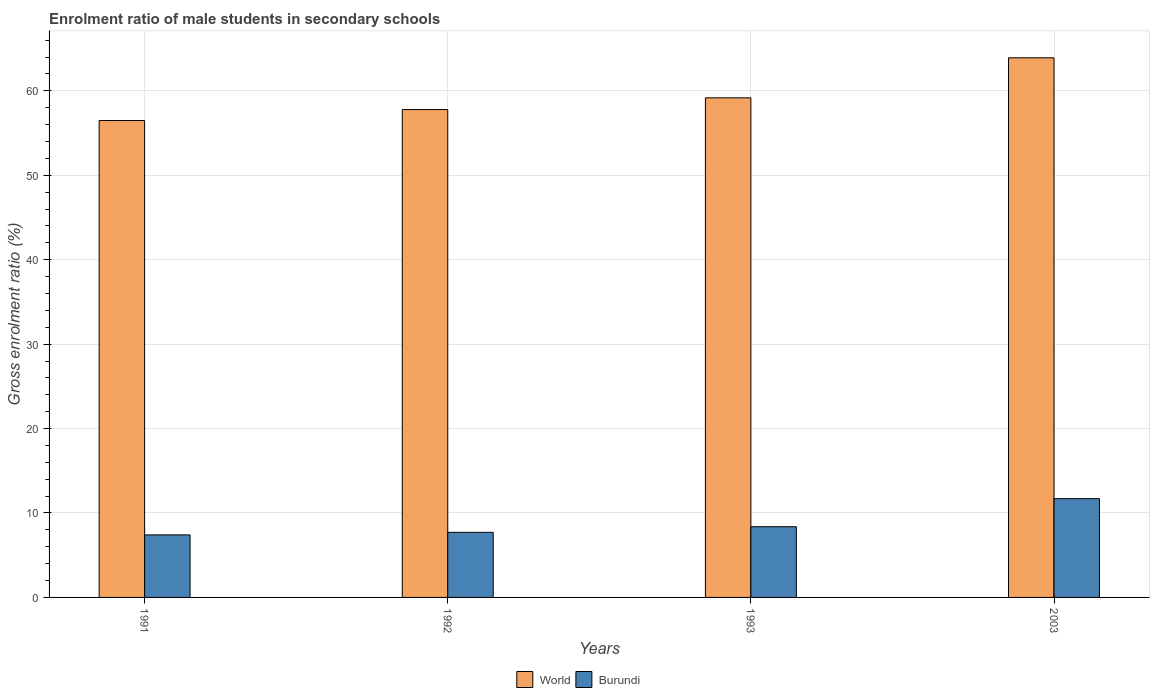How many groups of bars are there?
Offer a terse response. 4. What is the enrolment ratio of male students in secondary schools in Burundi in 2003?
Make the answer very short. 11.7. Across all years, what is the maximum enrolment ratio of male students in secondary schools in World?
Ensure brevity in your answer.  63.91. Across all years, what is the minimum enrolment ratio of male students in secondary schools in World?
Give a very brief answer. 56.48. In which year was the enrolment ratio of male students in secondary schools in Burundi maximum?
Provide a succinct answer. 2003. In which year was the enrolment ratio of male students in secondary schools in Burundi minimum?
Your answer should be very brief. 1991. What is the total enrolment ratio of male students in secondary schools in Burundi in the graph?
Provide a short and direct response. 35.18. What is the difference between the enrolment ratio of male students in secondary schools in World in 1991 and that in 2003?
Your answer should be very brief. -7.43. What is the difference between the enrolment ratio of male students in secondary schools in World in 1993 and the enrolment ratio of male students in secondary schools in Burundi in 1991?
Offer a very short reply. 51.77. What is the average enrolment ratio of male students in secondary schools in World per year?
Provide a succinct answer. 59.34. In the year 1992, what is the difference between the enrolment ratio of male students in secondary schools in Burundi and enrolment ratio of male students in secondary schools in World?
Provide a short and direct response. -50.07. What is the ratio of the enrolment ratio of male students in secondary schools in Burundi in 1991 to that in 2003?
Keep it short and to the point. 0.63. What is the difference between the highest and the second highest enrolment ratio of male students in secondary schools in Burundi?
Offer a very short reply. 3.32. What is the difference between the highest and the lowest enrolment ratio of male students in secondary schools in Burundi?
Give a very brief answer. 4.29. In how many years, is the enrolment ratio of male students in secondary schools in World greater than the average enrolment ratio of male students in secondary schools in World taken over all years?
Your answer should be very brief. 1. What does the 2nd bar from the left in 2003 represents?
Your answer should be compact. Burundi. What does the 1st bar from the right in 1991 represents?
Offer a terse response. Burundi. Are all the bars in the graph horizontal?
Provide a succinct answer. No. Are the values on the major ticks of Y-axis written in scientific E-notation?
Offer a very short reply. No. Does the graph contain grids?
Ensure brevity in your answer.  Yes. Where does the legend appear in the graph?
Ensure brevity in your answer.  Bottom center. How many legend labels are there?
Offer a terse response. 2. What is the title of the graph?
Make the answer very short. Enrolment ratio of male students in secondary schools. Does "Albania" appear as one of the legend labels in the graph?
Provide a succinct answer. No. What is the label or title of the X-axis?
Provide a short and direct response. Years. What is the Gross enrolment ratio (%) in World in 1991?
Keep it short and to the point. 56.48. What is the Gross enrolment ratio (%) in Burundi in 1991?
Keep it short and to the point. 7.41. What is the Gross enrolment ratio (%) of World in 1992?
Your response must be concise. 57.78. What is the Gross enrolment ratio (%) in Burundi in 1992?
Offer a terse response. 7.71. What is the Gross enrolment ratio (%) in World in 1993?
Give a very brief answer. 59.17. What is the Gross enrolment ratio (%) in Burundi in 1993?
Your response must be concise. 8.37. What is the Gross enrolment ratio (%) in World in 2003?
Give a very brief answer. 63.91. What is the Gross enrolment ratio (%) of Burundi in 2003?
Provide a short and direct response. 11.7. Across all years, what is the maximum Gross enrolment ratio (%) in World?
Offer a very short reply. 63.91. Across all years, what is the maximum Gross enrolment ratio (%) of Burundi?
Make the answer very short. 11.7. Across all years, what is the minimum Gross enrolment ratio (%) of World?
Provide a succinct answer. 56.48. Across all years, what is the minimum Gross enrolment ratio (%) of Burundi?
Your response must be concise. 7.41. What is the total Gross enrolment ratio (%) of World in the graph?
Offer a very short reply. 237.34. What is the total Gross enrolment ratio (%) in Burundi in the graph?
Give a very brief answer. 35.19. What is the difference between the Gross enrolment ratio (%) in World in 1991 and that in 1992?
Your response must be concise. -1.3. What is the difference between the Gross enrolment ratio (%) in Burundi in 1991 and that in 1992?
Keep it short and to the point. -0.3. What is the difference between the Gross enrolment ratio (%) of World in 1991 and that in 1993?
Offer a very short reply. -2.69. What is the difference between the Gross enrolment ratio (%) of Burundi in 1991 and that in 1993?
Give a very brief answer. -0.97. What is the difference between the Gross enrolment ratio (%) in World in 1991 and that in 2003?
Your answer should be compact. -7.43. What is the difference between the Gross enrolment ratio (%) in Burundi in 1991 and that in 2003?
Your answer should be very brief. -4.29. What is the difference between the Gross enrolment ratio (%) in World in 1992 and that in 1993?
Make the answer very short. -1.39. What is the difference between the Gross enrolment ratio (%) in Burundi in 1992 and that in 1993?
Give a very brief answer. -0.66. What is the difference between the Gross enrolment ratio (%) in World in 1992 and that in 2003?
Give a very brief answer. -6.13. What is the difference between the Gross enrolment ratio (%) in Burundi in 1992 and that in 2003?
Your response must be concise. -3.99. What is the difference between the Gross enrolment ratio (%) of World in 1993 and that in 2003?
Make the answer very short. -4.74. What is the difference between the Gross enrolment ratio (%) in Burundi in 1993 and that in 2003?
Offer a terse response. -3.32. What is the difference between the Gross enrolment ratio (%) in World in 1991 and the Gross enrolment ratio (%) in Burundi in 1992?
Provide a short and direct response. 48.77. What is the difference between the Gross enrolment ratio (%) in World in 1991 and the Gross enrolment ratio (%) in Burundi in 1993?
Make the answer very short. 48.11. What is the difference between the Gross enrolment ratio (%) of World in 1991 and the Gross enrolment ratio (%) of Burundi in 2003?
Give a very brief answer. 44.79. What is the difference between the Gross enrolment ratio (%) in World in 1992 and the Gross enrolment ratio (%) in Burundi in 1993?
Offer a terse response. 49.41. What is the difference between the Gross enrolment ratio (%) in World in 1992 and the Gross enrolment ratio (%) in Burundi in 2003?
Your answer should be compact. 46.08. What is the difference between the Gross enrolment ratio (%) of World in 1993 and the Gross enrolment ratio (%) of Burundi in 2003?
Provide a succinct answer. 47.47. What is the average Gross enrolment ratio (%) of World per year?
Your response must be concise. 59.34. What is the average Gross enrolment ratio (%) in Burundi per year?
Offer a very short reply. 8.8. In the year 1991, what is the difference between the Gross enrolment ratio (%) in World and Gross enrolment ratio (%) in Burundi?
Provide a succinct answer. 49.08. In the year 1992, what is the difference between the Gross enrolment ratio (%) of World and Gross enrolment ratio (%) of Burundi?
Your answer should be very brief. 50.07. In the year 1993, what is the difference between the Gross enrolment ratio (%) of World and Gross enrolment ratio (%) of Burundi?
Offer a very short reply. 50.8. In the year 2003, what is the difference between the Gross enrolment ratio (%) in World and Gross enrolment ratio (%) in Burundi?
Offer a very short reply. 52.21. What is the ratio of the Gross enrolment ratio (%) in World in 1991 to that in 1992?
Give a very brief answer. 0.98. What is the ratio of the Gross enrolment ratio (%) of Burundi in 1991 to that in 1992?
Your response must be concise. 0.96. What is the ratio of the Gross enrolment ratio (%) in World in 1991 to that in 1993?
Offer a very short reply. 0.95. What is the ratio of the Gross enrolment ratio (%) of Burundi in 1991 to that in 1993?
Make the answer very short. 0.88. What is the ratio of the Gross enrolment ratio (%) of World in 1991 to that in 2003?
Your answer should be very brief. 0.88. What is the ratio of the Gross enrolment ratio (%) of Burundi in 1991 to that in 2003?
Make the answer very short. 0.63. What is the ratio of the Gross enrolment ratio (%) in World in 1992 to that in 1993?
Your response must be concise. 0.98. What is the ratio of the Gross enrolment ratio (%) of Burundi in 1992 to that in 1993?
Provide a succinct answer. 0.92. What is the ratio of the Gross enrolment ratio (%) in World in 1992 to that in 2003?
Provide a short and direct response. 0.9. What is the ratio of the Gross enrolment ratio (%) in Burundi in 1992 to that in 2003?
Provide a succinct answer. 0.66. What is the ratio of the Gross enrolment ratio (%) in World in 1993 to that in 2003?
Your answer should be very brief. 0.93. What is the ratio of the Gross enrolment ratio (%) in Burundi in 1993 to that in 2003?
Your response must be concise. 0.72. What is the difference between the highest and the second highest Gross enrolment ratio (%) in World?
Your response must be concise. 4.74. What is the difference between the highest and the second highest Gross enrolment ratio (%) of Burundi?
Your answer should be compact. 3.32. What is the difference between the highest and the lowest Gross enrolment ratio (%) in World?
Provide a succinct answer. 7.43. What is the difference between the highest and the lowest Gross enrolment ratio (%) in Burundi?
Your answer should be compact. 4.29. 